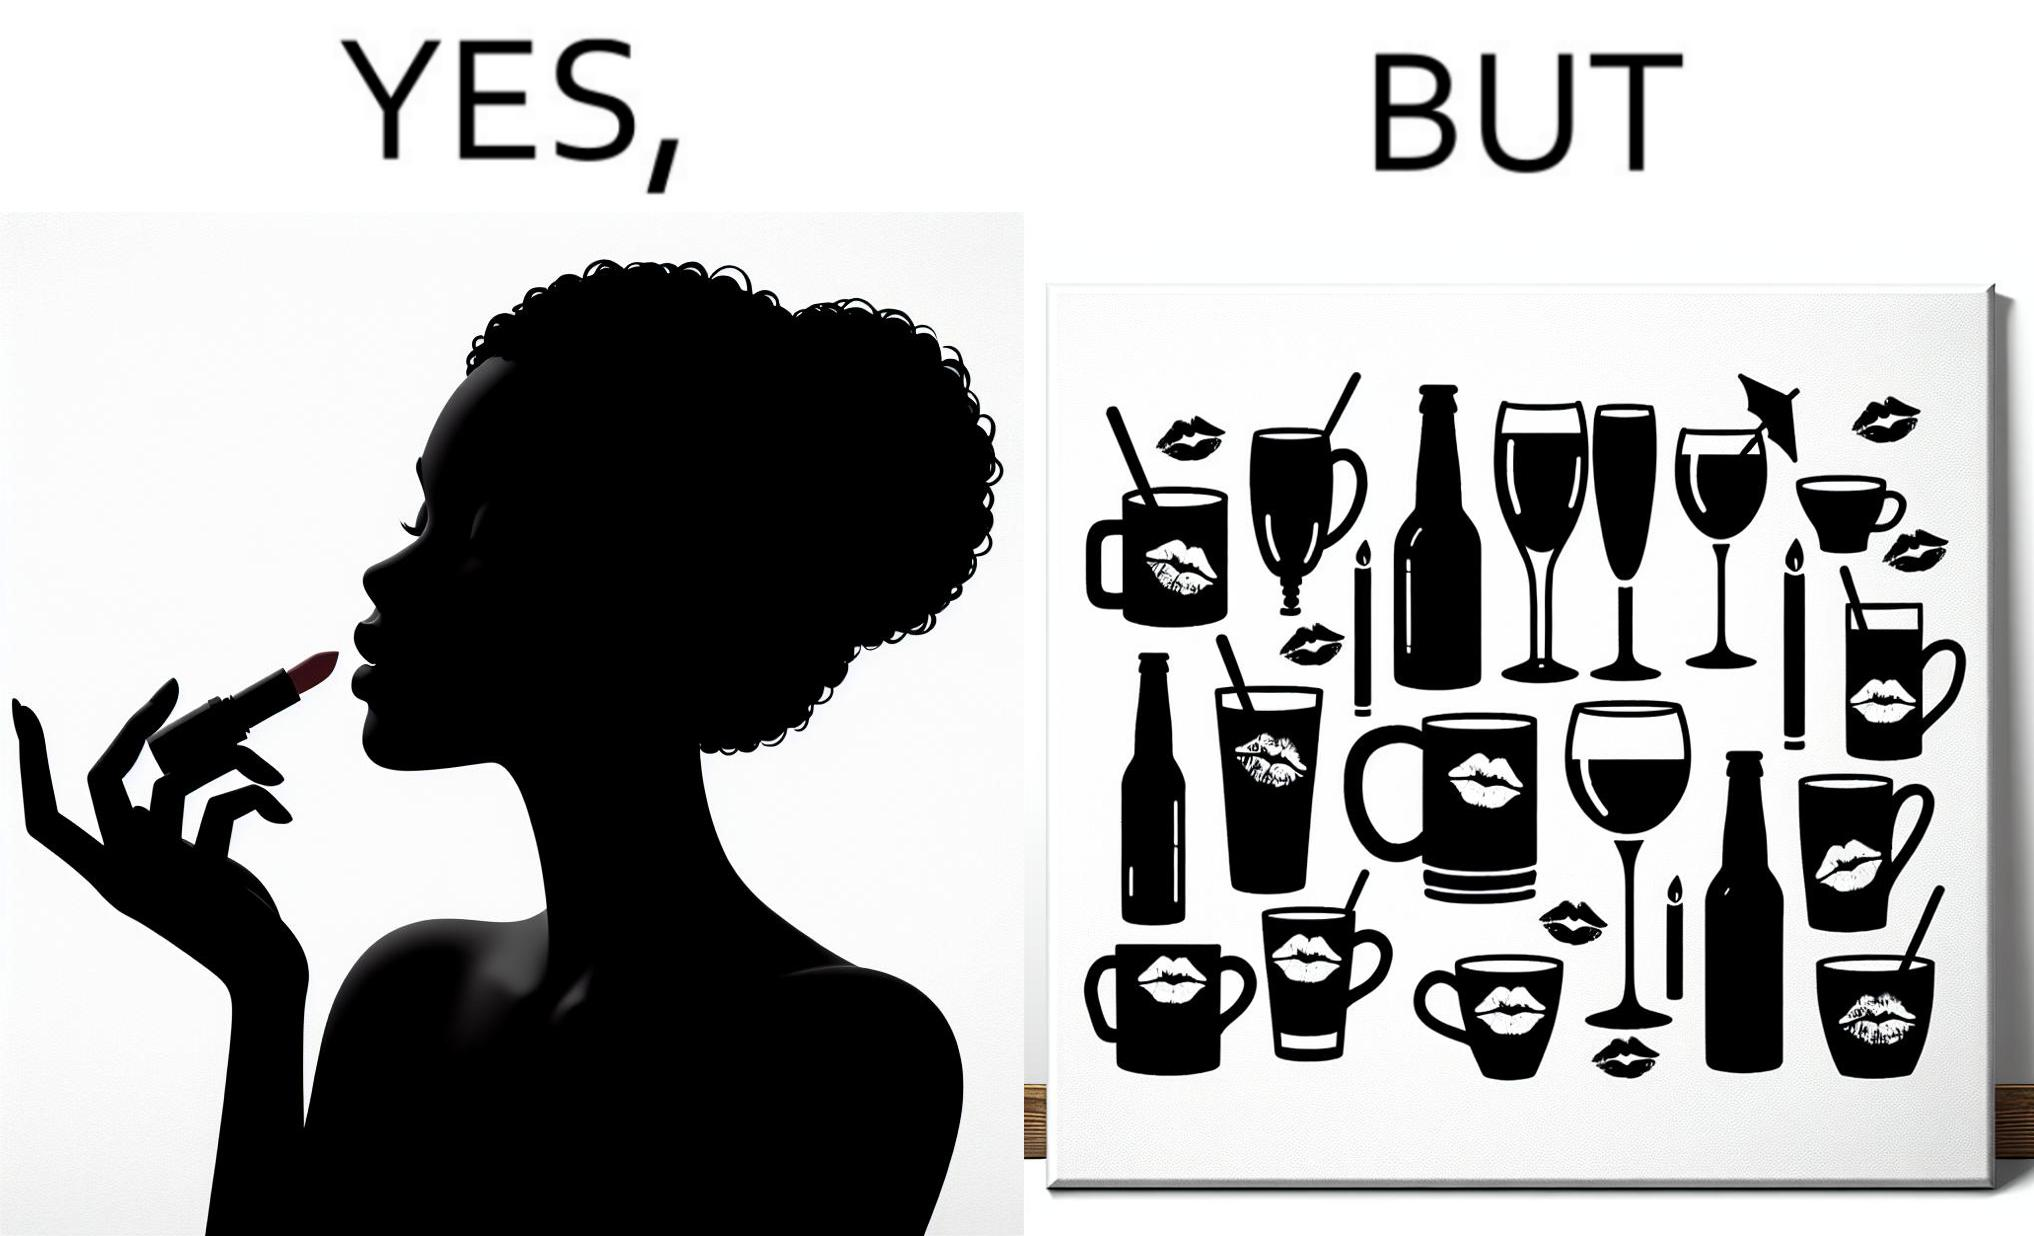What is shown in the left half versus the right half of this image? In the left part of the image: a person applying lipstick, probably a girl or woman In the right part of the image: lipstick stains on various mugs and glasses 